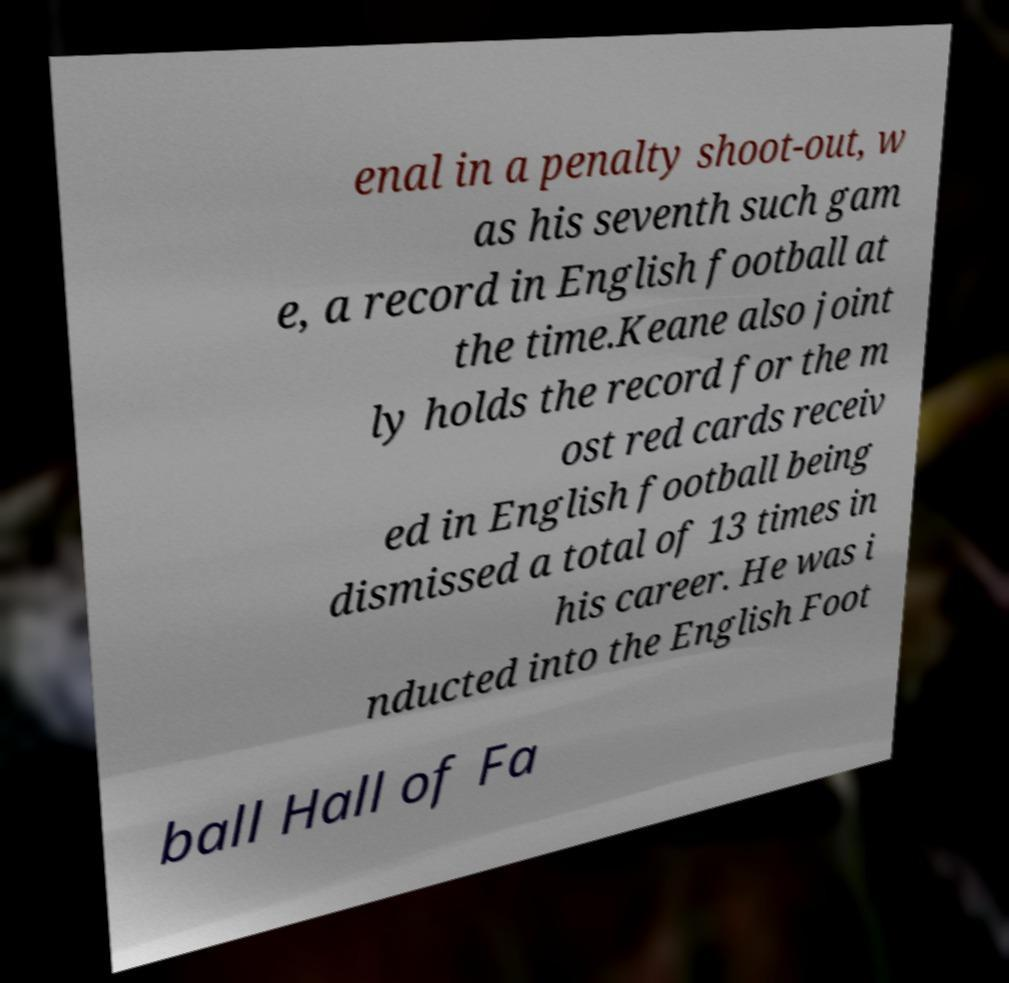Could you assist in decoding the text presented in this image and type it out clearly? enal in a penalty shoot-out, w as his seventh such gam e, a record in English football at the time.Keane also joint ly holds the record for the m ost red cards receiv ed in English football being dismissed a total of 13 times in his career. He was i nducted into the English Foot ball Hall of Fa 